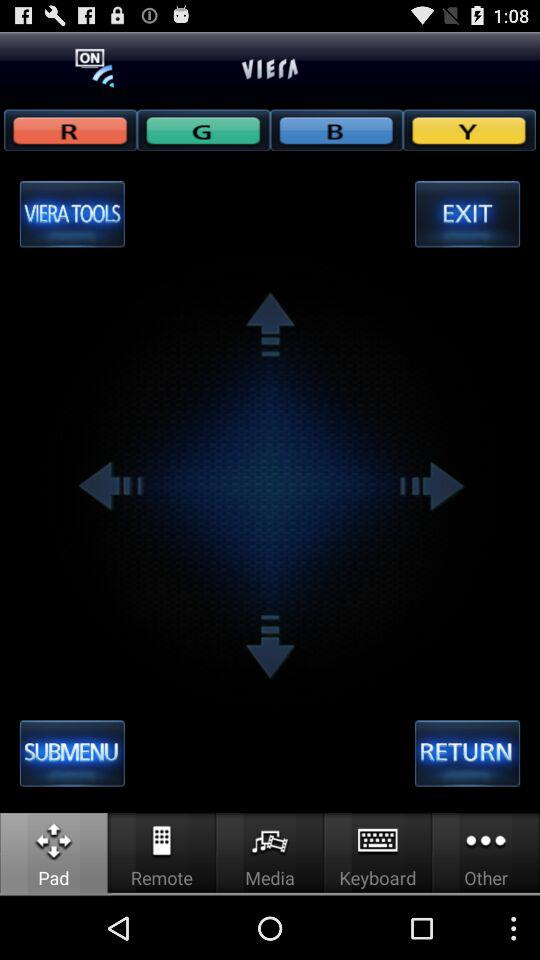Which button is selected? The selected button is "Pad". 